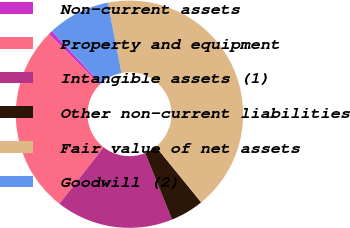Convert chart to OTSL. <chart><loc_0><loc_0><loc_500><loc_500><pie_chart><fcel>Non-current assets<fcel>Property and equipment<fcel>Intangible assets (1)<fcel>Other non-current liabilities<fcel>Fair value of net assets<fcel>Goodwill (2)<nl><fcel>0.59%<fcel>26.89%<fcel>16.68%<fcel>4.75%<fcel>42.18%<fcel>8.91%<nl></chart> 